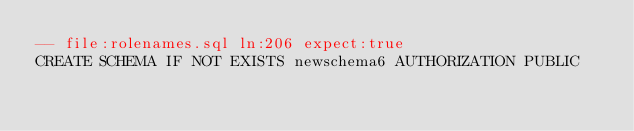Convert code to text. <code><loc_0><loc_0><loc_500><loc_500><_SQL_>-- file:rolenames.sql ln:206 expect:true
CREATE SCHEMA IF NOT EXISTS newschema6 AUTHORIZATION PUBLIC
</code> 